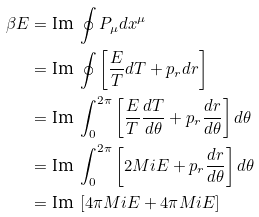Convert formula to latex. <formula><loc_0><loc_0><loc_500><loc_500>\beta E & = \text {Im } \oint P _ { \mu } d x ^ { \mu } \\ & = \text {Im } \oint \left [ \frac { E } { T } d T + p _ { r } d r \right ] \\ & = \text {Im } \int _ { 0 } ^ { 2 \pi } \left [ \frac { E } { T } \frac { d T } { d \theta } + p _ { r } \frac { d r } { d \theta } \right ] d \theta \\ & = \text {Im } \int _ { 0 } ^ { 2 \pi } \left [ 2 M i E + p _ { r } \frac { d r } { d \theta } \right ] d \theta \\ & = \text {Im } \left [ 4 \pi M i E + 4 \pi M i E \right ]</formula> 